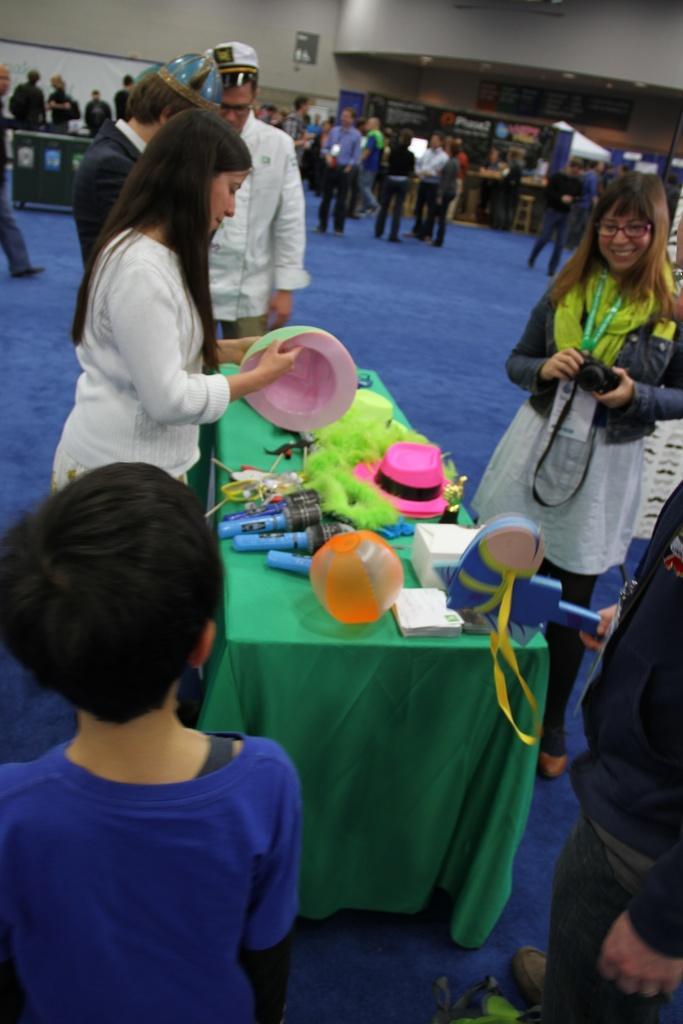Describe this image in one or two sentences. There is a woman wearing white dress is holding an object in her hand and there is a table in front of her which has few objects placed on it and there are few people standing beside her and there is another woman holding camera and standing in the right corner and there is another person holding an object beside her. 